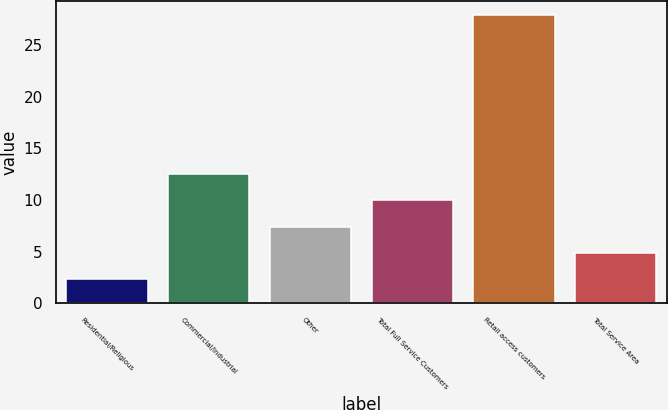Convert chart to OTSL. <chart><loc_0><loc_0><loc_500><loc_500><bar_chart><fcel>Residential/Religious<fcel>Commercial/Industrial<fcel>Other<fcel>Total Full Service Customers<fcel>Retail access customers<fcel>Total Service Area<nl><fcel>2.3<fcel>12.54<fcel>7.42<fcel>9.98<fcel>27.9<fcel>4.86<nl></chart> 